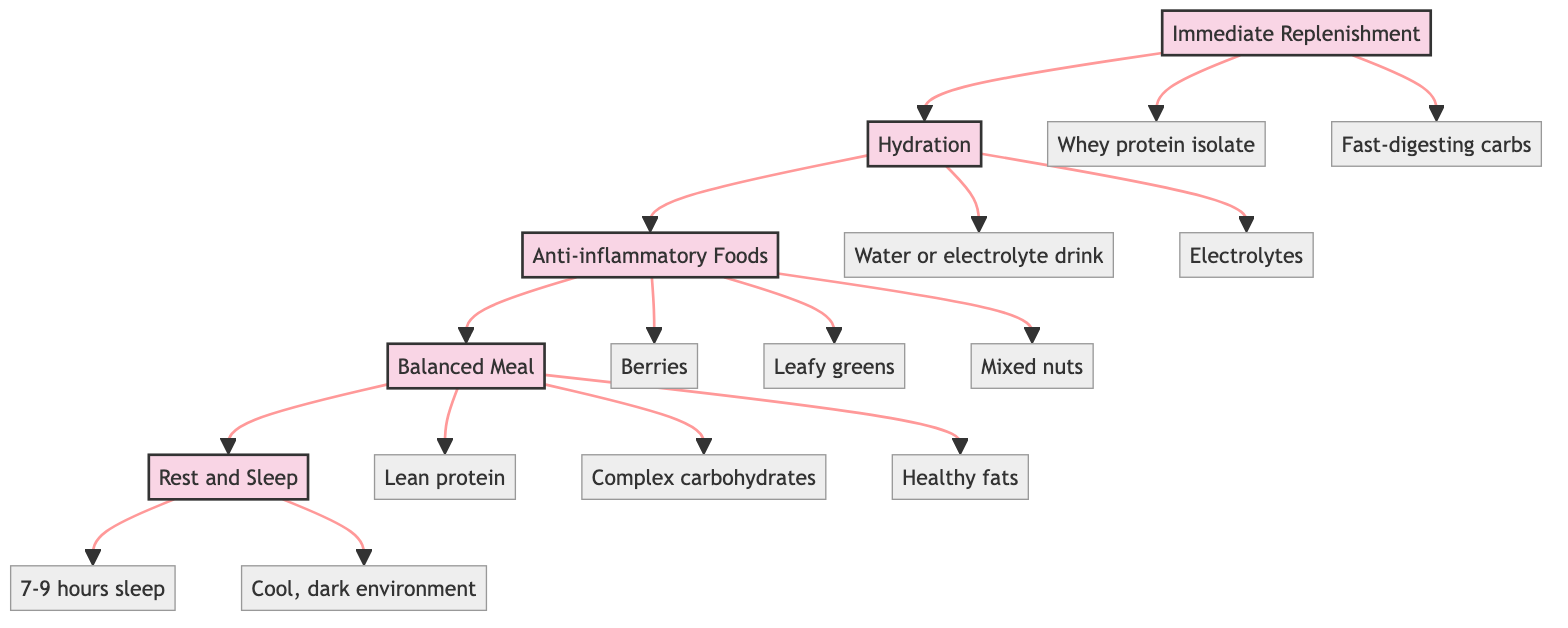What is the first step in the Post-Session Recovery Nutrition Pathway? The diagram identifies "Immediate Replenishment" as the first step. This step is connected as the starting point of the pathway.
Answer: Immediate Replenishment How many steps are there in the Post-Session Recovery Nutrition Pathway? Counting the individual steps visually represented in the diagram shows a total of five distinct steps, from Immediate Replenishment to Rest and Sleep.
Answer: 5 What component is associated with Immediate Replenishment? The diagram lists "Whey protein isolate" and "Fast-digesting carbs" as the components for Immediate Replenishment, showing the specific nutrition elements needed.
Answer: Whey protein isolate, Fast-digesting carbs What fluids are recommended during Hydration? The diagram clearly states that 500ml of water or an electrolyte drink is recommended for hydration, indicating the specific volume and type of fluid.
Answer: 500ml of water or electrolyte drink Which step focuses on reducing inflammation? The diagram specifically indicates "Anti-inflammatory Foods" as the step aimed at reducing inflammation post-gaming session. This is the third step identified in the sequence.
Answer: Anti-inflammatory Foods What is the last step depicted in the diagram? The diagram concludes with "Rest and Sleep" as the final step, indicating the importance of rest in the recovery process.
Answer: Rest and Sleep How many components are listed under Balanced Meal? Under "Balanced Meal," there are three components listed: lean protein, complex carbohydrates, and healthy fats, totaling three distinct elements necessary for the meal.
Answer: 3 What is the recommended sleep duration in the last step? The diagram specifies a recommended sleep duration of "7-9 hours," providing a specific range to ensure adequate recovery.
Answer: 7-9 hours What is the relationship between Hydration and Anti-inflammatory Foods? The diagram shows that Hydration leads to Anti-inflammatory Foods, indicating that after rehydrating, the next step is to focus on consuming anti-inflammatory foods.
Answer: Hydration leads to Anti-inflammatory Foods 